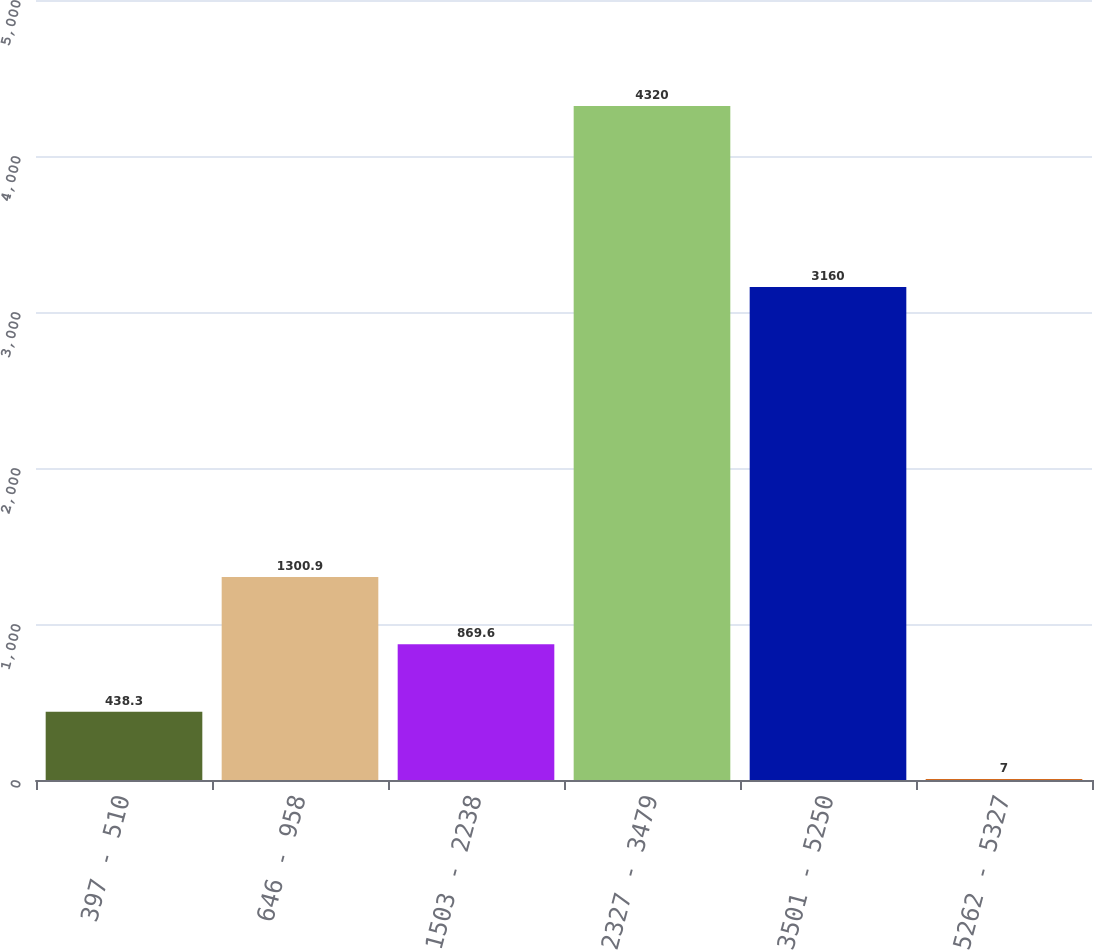Convert chart. <chart><loc_0><loc_0><loc_500><loc_500><bar_chart><fcel>397 - 510<fcel>646 - 958<fcel>1503 - 2238<fcel>2327 - 3479<fcel>3501 - 5250<fcel>5262 - 5327<nl><fcel>438.3<fcel>1300.9<fcel>869.6<fcel>4320<fcel>3160<fcel>7<nl></chart> 